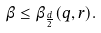<formula> <loc_0><loc_0><loc_500><loc_500>\beta \leq \beta _ { \frac { d } { 2 } } ( q , r ) .</formula> 